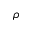Convert formula to latex. <formula><loc_0><loc_0><loc_500><loc_500>\rho</formula> 